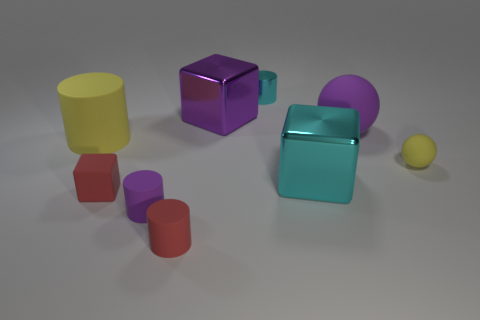Subtract 1 cylinders. How many cylinders are left? 3 Add 1 tiny matte cubes. How many objects exist? 10 Subtract all blocks. How many objects are left? 6 Subtract 1 purple cylinders. How many objects are left? 8 Subtract all cubes. Subtract all rubber balls. How many objects are left? 4 Add 7 small yellow objects. How many small yellow objects are left? 8 Add 1 matte objects. How many matte objects exist? 7 